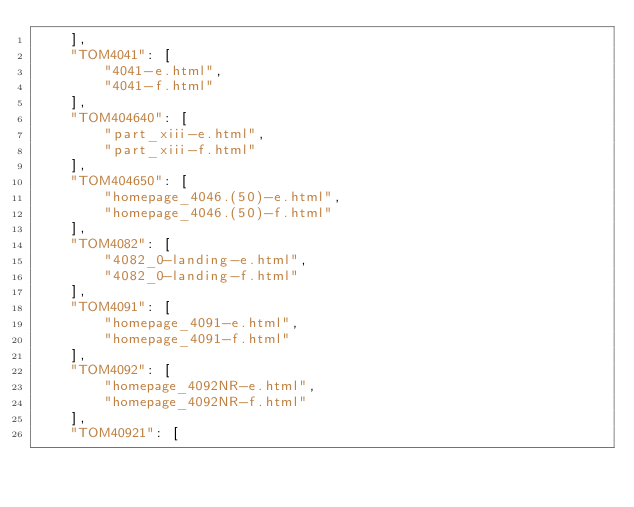<code> <loc_0><loc_0><loc_500><loc_500><_JavaScript_>	],
	"TOM4041": [
		"4041-e.html",
		"4041-f.html"
	],
	"TOM404640": [
		"part_xiii-e.html",
		"part_xiii-f.html"
	],
	"TOM404650": [
		"homepage_4046.(50)-e.html",
		"homepage_4046.(50)-f.html"
	],
	"TOM4082": [
		"4082_0-landing-e.html",
		"4082_0-landing-f.html"
	],
	"TOM4091": [
		"homepage_4091-e.html",
		"homepage_4091-f.html"
	],
	"TOM4092": [
		"homepage_4092NR-e.html",
		"homepage_4092NR-f.html"
	],
	"TOM40921": [</code> 